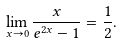Convert formula to latex. <formula><loc_0><loc_0><loc_500><loc_500>\lim _ { x \to 0 } \frac { x } { e ^ { 2 x } - 1 } = \frac { 1 } { 2 } .</formula> 